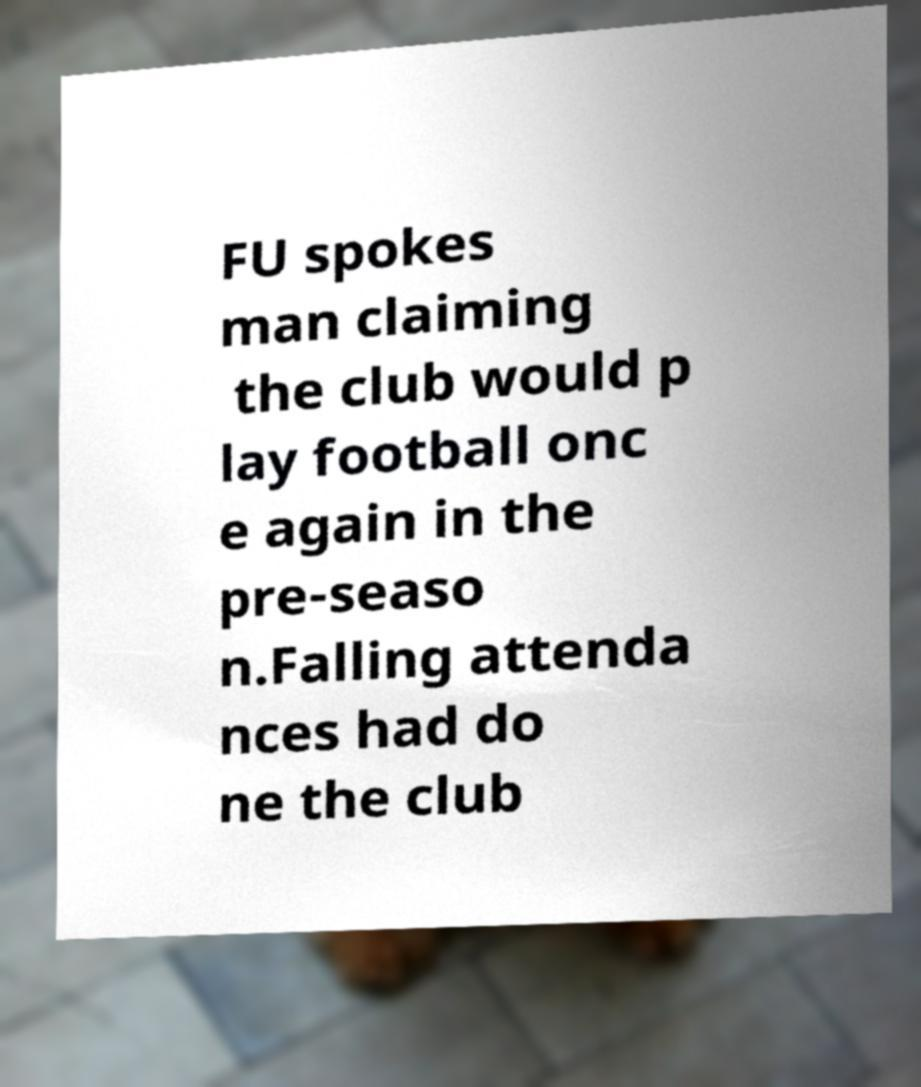Could you extract and type out the text from this image? FU spokes man claiming the club would p lay football onc e again in the pre-seaso n.Falling attenda nces had do ne the club 